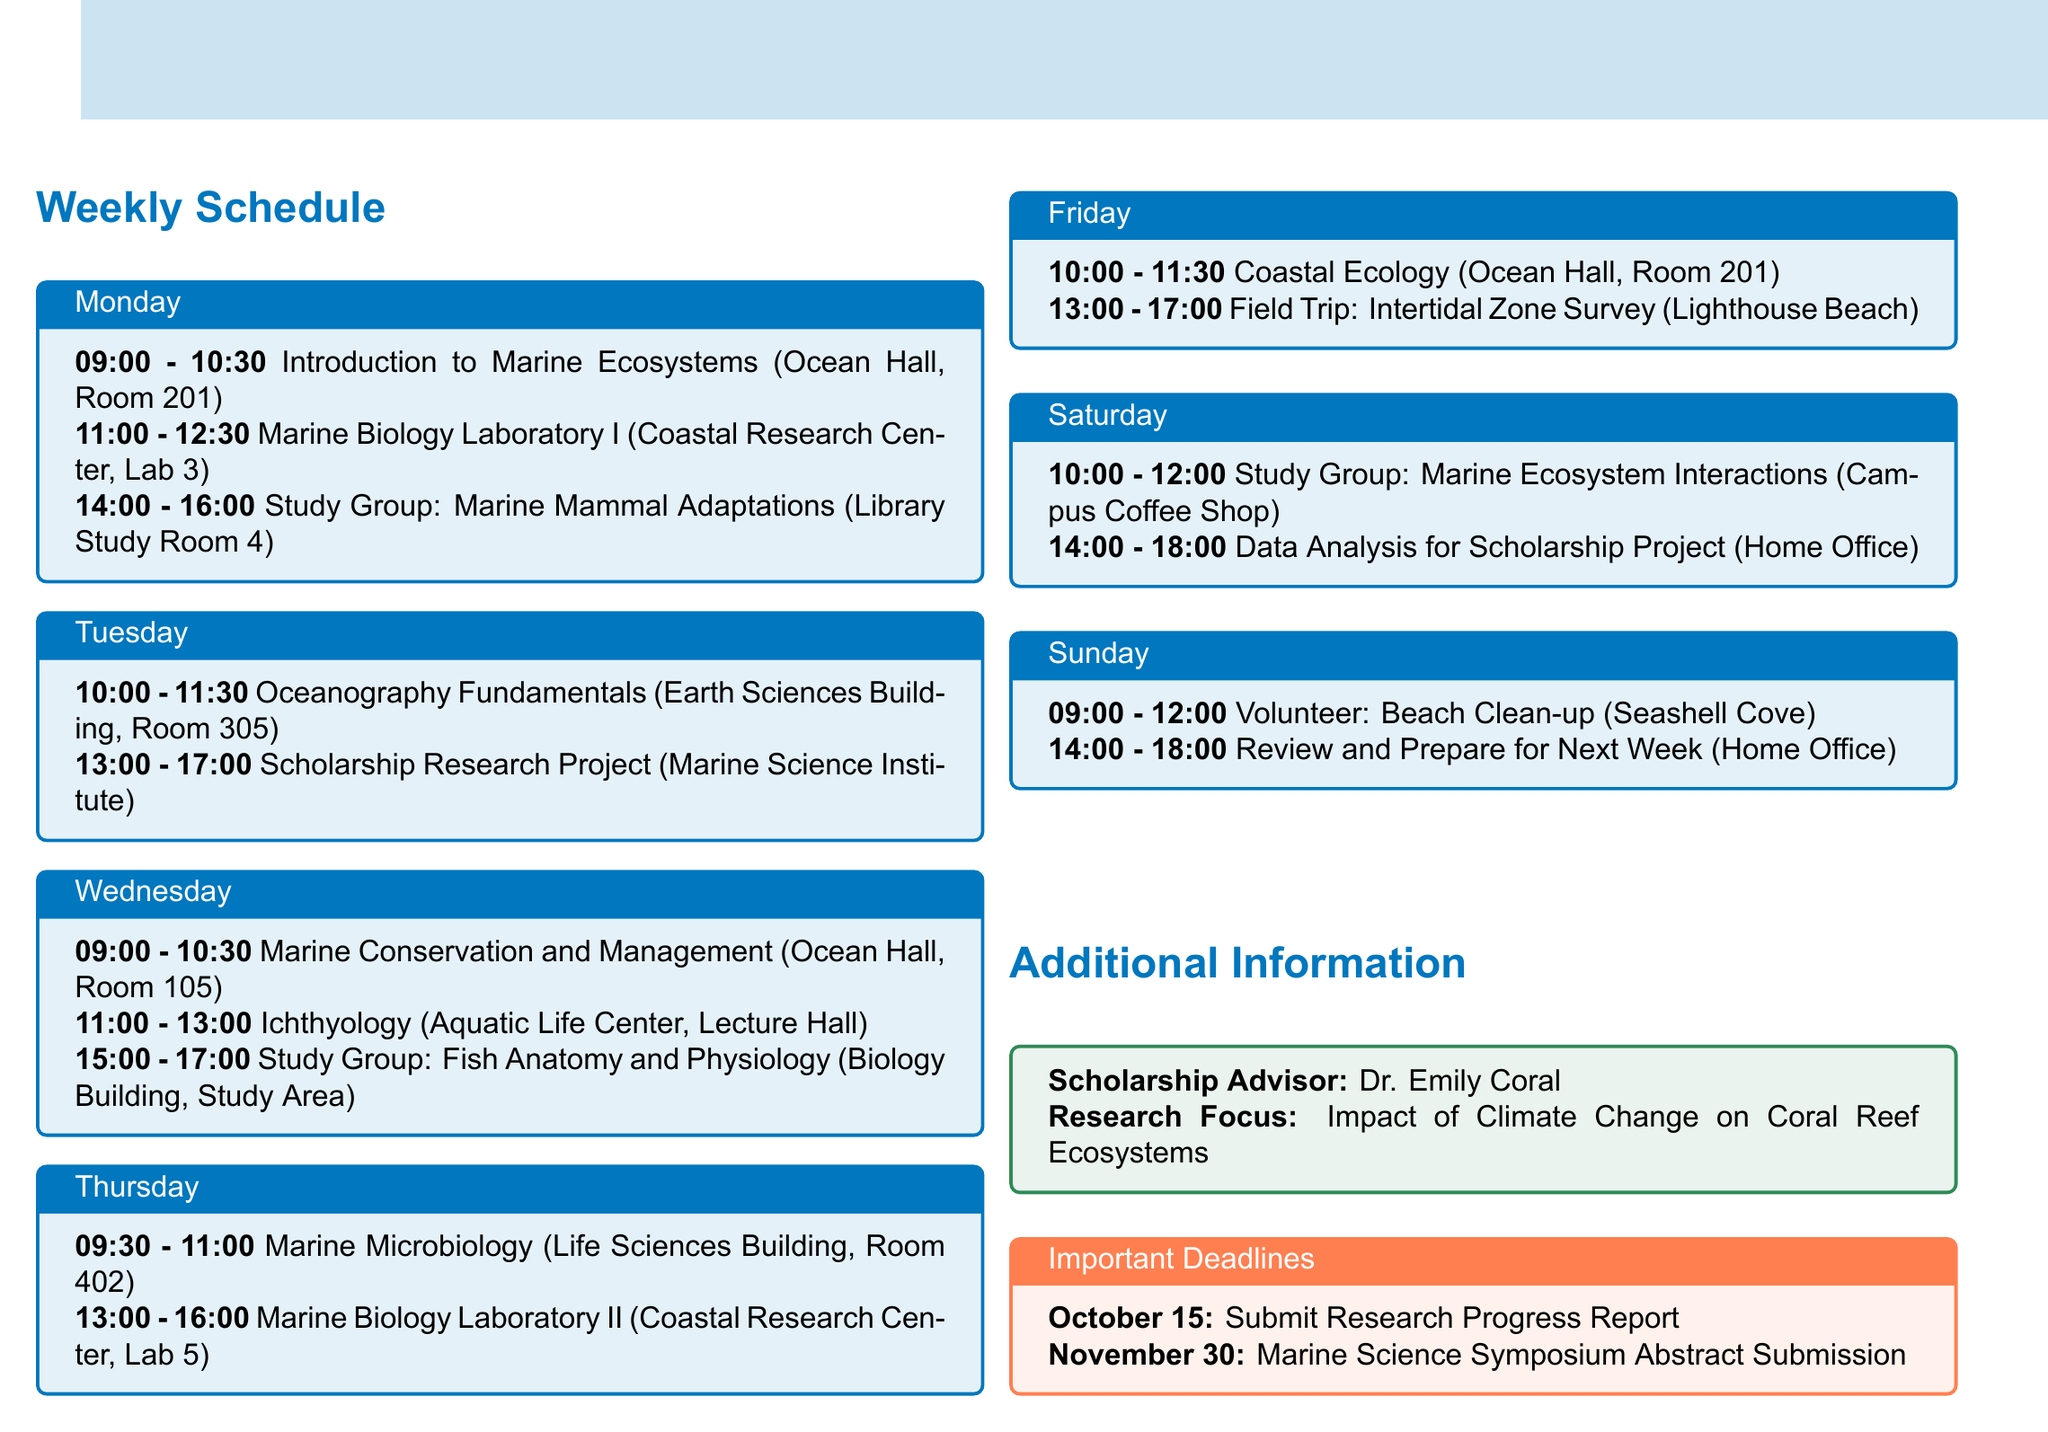What is the first class on Monday? The first class listed for Monday is "Introduction to Marine Ecosystems".
Answer: Introduction to Marine Ecosystems How long is the Marine Biology Laboratory I session? The duration of the Marine Biology Laboratory I class is mentioned as 1 hour and 30 minutes.
Answer: 1 hour 30 minutes What day is the study group on Marine Mammal Adaptations scheduled? The schedule shows that this study group takes place on Monday.
Answer: Monday What is the location for the Coastal Ecology class? The location for the Coastal Ecology class is specified in the document as Ocean Hall, Room 201.
Answer: Ocean Hall, Room 201 Which activity is scheduled on Sunday from 09:00 to 12:00? The document states that a Beach Clean-up is the activity for this time on Sunday.
Answer: Beach Clean-up What time does the research time for the scholarship project begin on Tuesday? The research time for the scholarship project starts at 1:00 PM, as noted in the schedule.
Answer: 1:00 PM Which course is focused on Marine Microbiology? The document indicates that the course on Marine Microbiology is scheduled on Thursday.
Answer: Marine Microbiology What is the focus of the scholarship research project? The focus of the scholarship research project is stated as the "Impact of Climate Change on Coral Reef Ecosystems".
Answer: Impact of Climate Change on Coral Reef Ecosystems When is the deadline to submit the Research Progress Report? The document specifies the deadline for this report as October 15.
Answer: October 15 